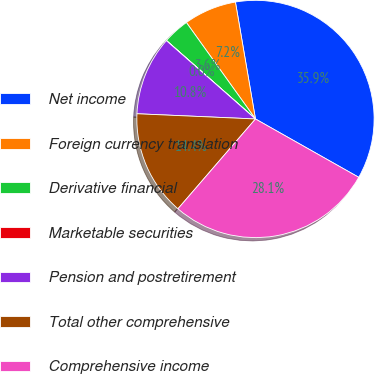<chart> <loc_0><loc_0><loc_500><loc_500><pie_chart><fcel>Net income<fcel>Foreign currency translation<fcel>Derivative financial<fcel>Marketable securities<fcel>Pension and postretirement<fcel>Total other comprehensive<fcel>Comprehensive income<nl><fcel>35.89%<fcel>7.19%<fcel>3.61%<fcel>0.02%<fcel>10.78%<fcel>14.37%<fcel>28.15%<nl></chart> 